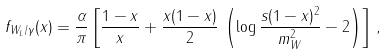<formula> <loc_0><loc_0><loc_500><loc_500>f _ { W _ { L } / \gamma } ( x ) = \frac { \alpha } { \pi } \left [ \frac { 1 - x } { x } + \frac { x ( 1 - x ) } { 2 } \, \left ( \log \frac { s ( 1 - x ) ^ { 2 } } { m _ { W } ^ { 2 } } - 2 \right ) \right ] \, ,</formula> 